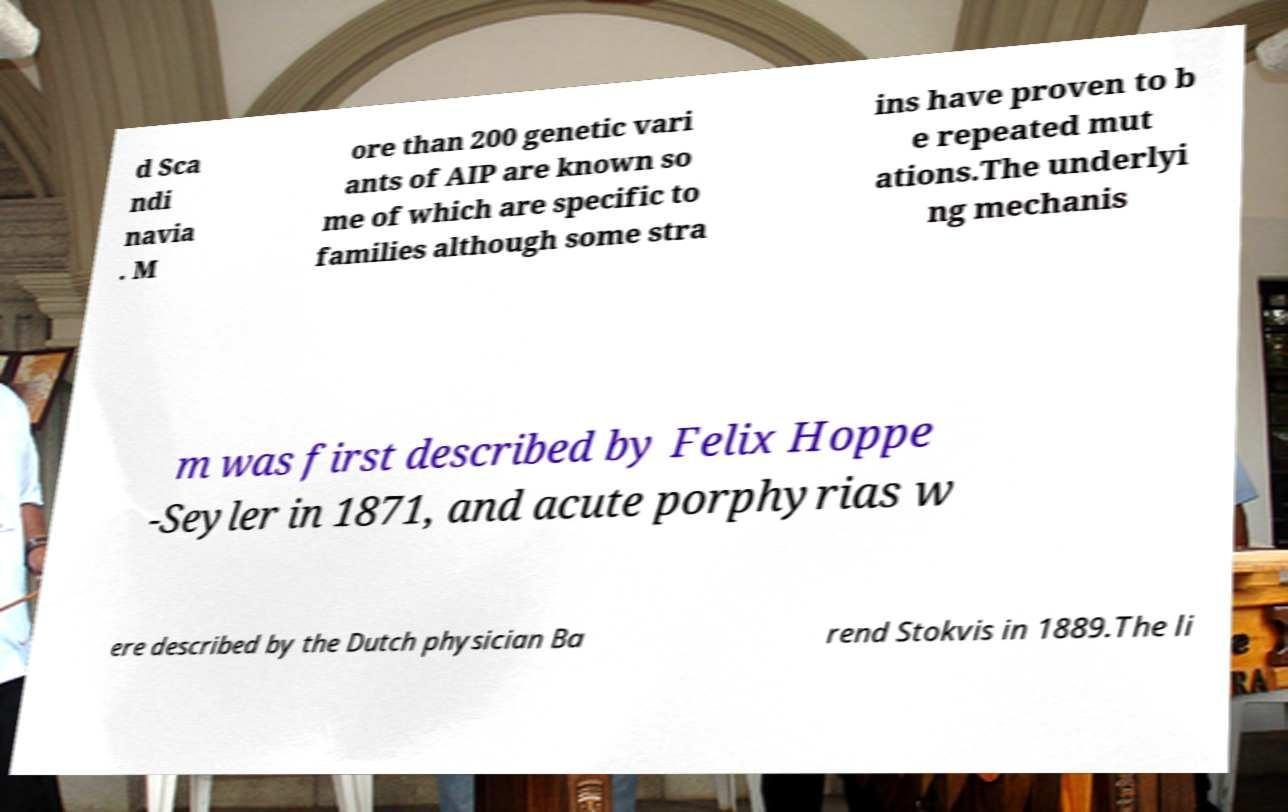Please read and relay the text visible in this image. What does it say? d Sca ndi navia . M ore than 200 genetic vari ants of AIP are known so me of which are specific to families although some stra ins have proven to b e repeated mut ations.The underlyi ng mechanis m was first described by Felix Hoppe -Seyler in 1871, and acute porphyrias w ere described by the Dutch physician Ba rend Stokvis in 1889.The li 